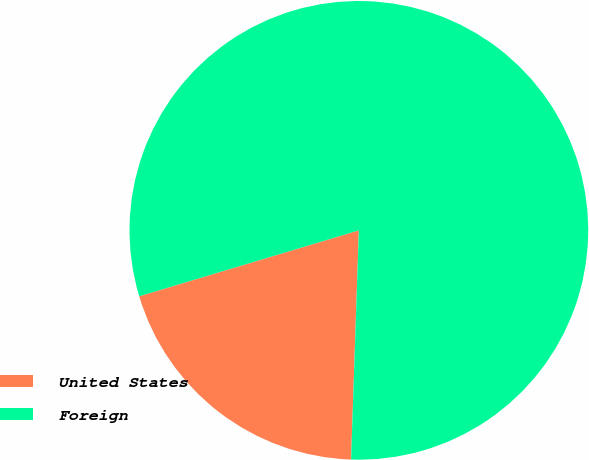Convert chart. <chart><loc_0><loc_0><loc_500><loc_500><pie_chart><fcel>United States<fcel>Foreign<nl><fcel>19.82%<fcel>80.18%<nl></chart> 